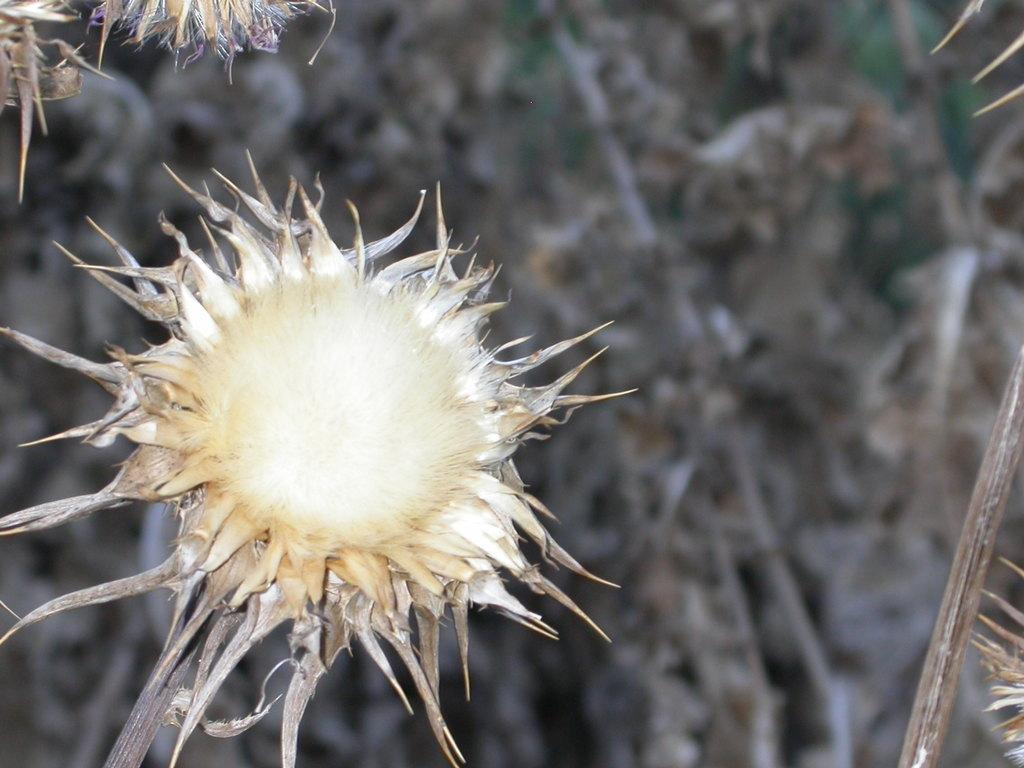What type of plant is present in the image? There is a flower and a dry plant in the image. Can you describe the background of the flower? The background of the flower is blue. What type of glue is being used to hold the flower in the image? There is no glue present in the image, and the flower is not being held in place by any adhesive. 